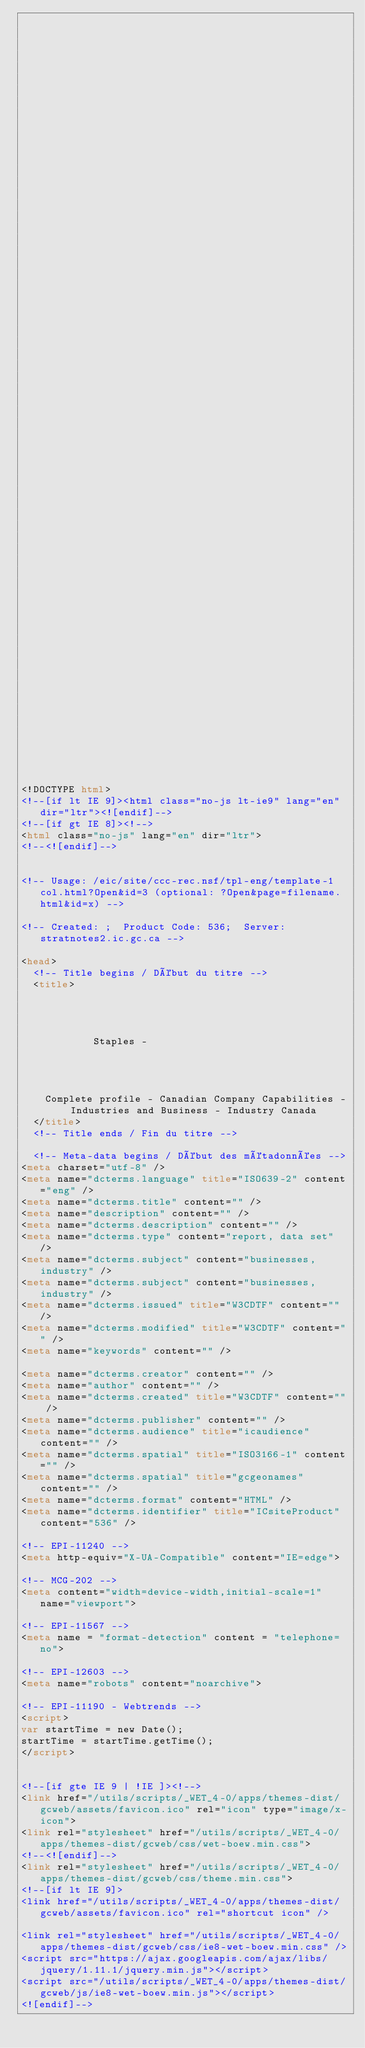<code> <loc_0><loc_0><loc_500><loc_500><_HTML_>


















	






  
  
  
  































	
	
	



<!DOCTYPE html>
<!--[if lt IE 9]><html class="no-js lt-ie9" lang="en" dir="ltr"><![endif]-->
<!--[if gt IE 8]><!-->
<html class="no-js" lang="en" dir="ltr">
<!--<![endif]-->


<!-- Usage: /eic/site/ccc-rec.nsf/tpl-eng/template-1col.html?Open&id=3 (optional: ?Open&page=filename.html&id=x) -->

<!-- Created: ;  Product Code: 536;  Server: stratnotes2.ic.gc.ca -->

<head>
	<!-- Title begins / Début du titre -->
	<title>
    
            
        
          
            Staples -
          
        
      
    
    Complete profile - Canadian Company Capabilities - Industries and Business - Industry Canada
  </title>
	<!-- Title ends / Fin du titre -->
 
	<!-- Meta-data begins / Début des métadonnées -->
<meta charset="utf-8" />
<meta name="dcterms.language" title="ISO639-2" content="eng" />
<meta name="dcterms.title" content="" />
<meta name="description" content="" />
<meta name="dcterms.description" content="" />
<meta name="dcterms.type" content="report, data set" />
<meta name="dcterms.subject" content="businesses, industry" />
<meta name="dcterms.subject" content="businesses, industry" />
<meta name="dcterms.issued" title="W3CDTF" content="" />
<meta name="dcterms.modified" title="W3CDTF" content="" />
<meta name="keywords" content="" />

<meta name="dcterms.creator" content="" />
<meta name="author" content="" />
<meta name="dcterms.created" title="W3CDTF" content="" />
<meta name="dcterms.publisher" content="" />
<meta name="dcterms.audience" title="icaudience" content="" />
<meta name="dcterms.spatial" title="ISO3166-1" content="" />
<meta name="dcterms.spatial" title="gcgeonames" content="" />
<meta name="dcterms.format" content="HTML" />
<meta name="dcterms.identifier" title="ICsiteProduct" content="536" />

<!-- EPI-11240 -->
<meta http-equiv="X-UA-Compatible" content="IE=edge">

<!-- MCG-202 -->
<meta content="width=device-width,initial-scale=1" name="viewport">

<!-- EPI-11567 -->
<meta name = "format-detection" content = "telephone=no">

<!-- EPI-12603 -->
<meta name="robots" content="noarchive">

<!-- EPI-11190 - Webtrends -->
<script>
var startTime = new Date();
startTime = startTime.getTime();
</script>


<!--[if gte IE 9 | !IE ]><!-->
<link href="/utils/scripts/_WET_4-0/apps/themes-dist/gcweb/assets/favicon.ico" rel="icon" type="image/x-icon">
<link rel="stylesheet" href="/utils/scripts/_WET_4-0/apps/themes-dist/gcweb/css/wet-boew.min.css">
<!--<![endif]-->
<link rel="stylesheet" href="/utils/scripts/_WET_4-0/apps/themes-dist/gcweb/css/theme.min.css">
<!--[if lt IE 9]>
<link href="/utils/scripts/_WET_4-0/apps/themes-dist/gcweb/assets/favicon.ico" rel="shortcut icon" />

<link rel="stylesheet" href="/utils/scripts/_WET_4-0/apps/themes-dist/gcweb/css/ie8-wet-boew.min.css" />
<script src="https://ajax.googleapis.com/ajax/libs/jquery/1.11.1/jquery.min.js"></script>
<script src="/utils/scripts/_WET_4-0/apps/themes-dist/gcweb/js/ie8-wet-boew.min.js"></script>
<![endif]--></code> 